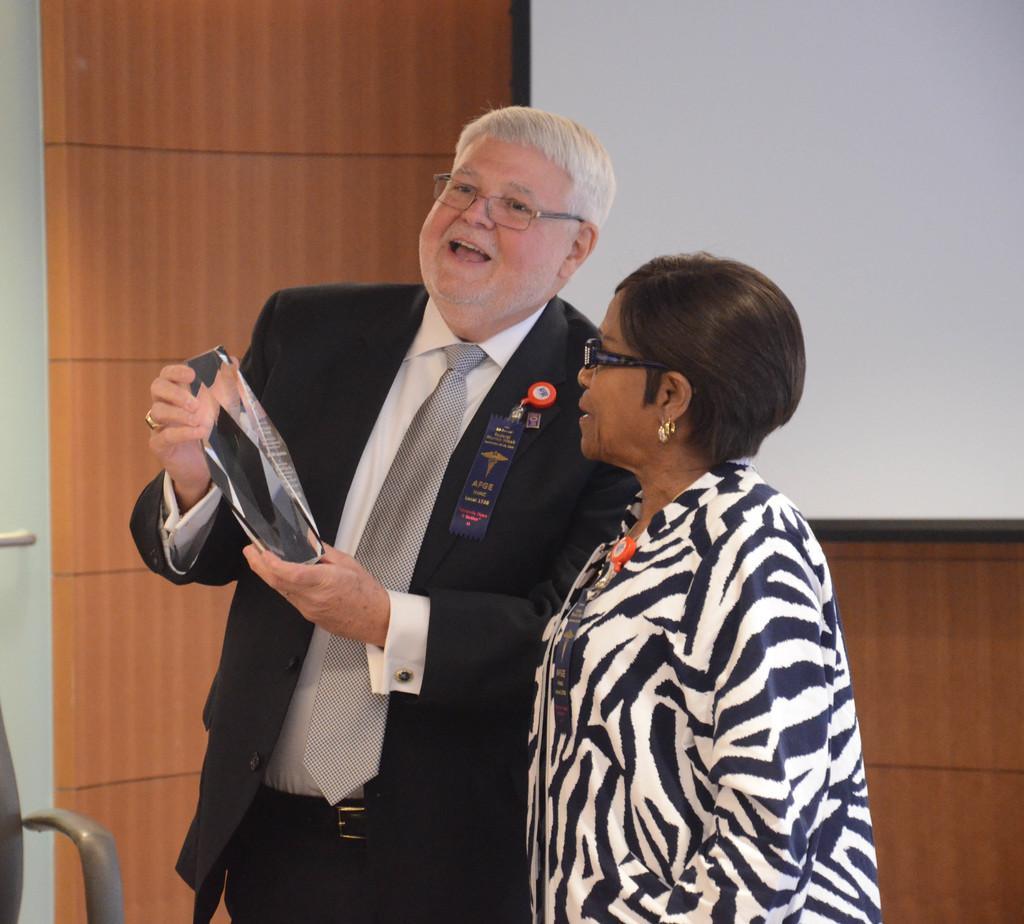How would you summarize this image in a sentence or two? In this image, we can see a man in a suit is smiling and wearing glasses. He is holding some object. Beside him, there is a woman is standing. Background there is a wall and screen. Left side bottom corner, we can see a handle. 